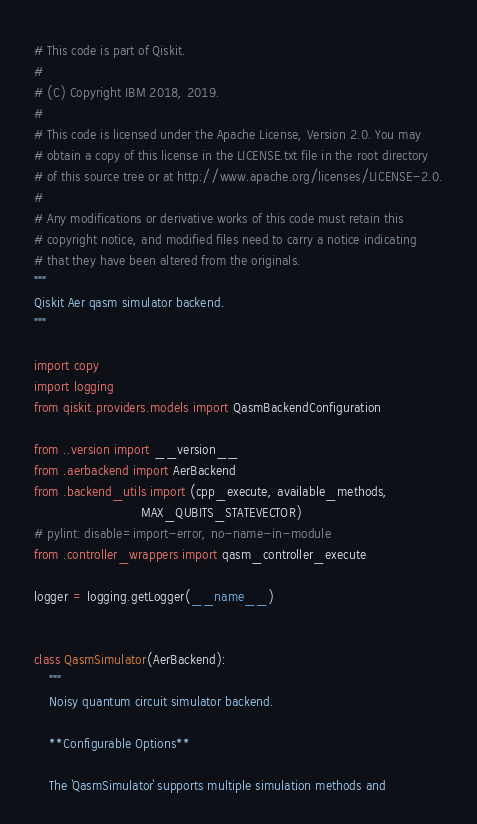<code> <loc_0><loc_0><loc_500><loc_500><_Python_># This code is part of Qiskit.
#
# (C) Copyright IBM 2018, 2019.
#
# This code is licensed under the Apache License, Version 2.0. You may
# obtain a copy of this license in the LICENSE.txt file in the root directory
# of this source tree or at http://www.apache.org/licenses/LICENSE-2.0.
#
# Any modifications or derivative works of this code must retain this
# copyright notice, and modified files need to carry a notice indicating
# that they have been altered from the originals.
"""
Qiskit Aer qasm simulator backend.
"""

import copy
import logging
from qiskit.providers.models import QasmBackendConfiguration

from ..version import __version__
from .aerbackend import AerBackend
from .backend_utils import (cpp_execute, available_methods,
                            MAX_QUBITS_STATEVECTOR)
# pylint: disable=import-error, no-name-in-module
from .controller_wrappers import qasm_controller_execute

logger = logging.getLogger(__name__)


class QasmSimulator(AerBackend):
    """
    Noisy quantum circuit simulator backend.

    **Configurable Options**

    The `QasmSimulator` supports multiple simulation methods and</code> 